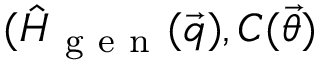<formula> <loc_0><loc_0><loc_500><loc_500>( \hat { H } _ { g e n } ( \vec { q } ) , C ( \vec { \theta } )</formula> 